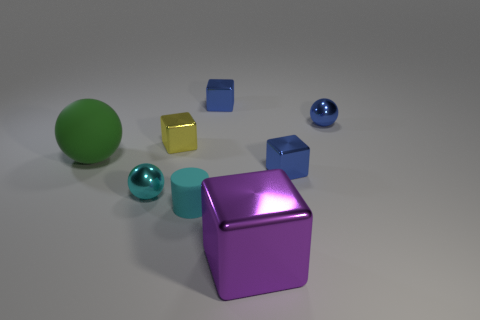How many things are either tiny blue metallic cubes that are behind the small yellow shiny cube or green things?
Keep it short and to the point. 2. Are there the same number of small spheres that are on the left side of the purple metallic block and tiny metallic cubes in front of the tiny yellow metal object?
Offer a very short reply. Yes. The tiny cyan cylinder to the left of the tiny blue metal object that is to the left of the block right of the purple thing is made of what material?
Make the answer very short. Rubber. How big is the thing that is both behind the purple cube and in front of the cyan sphere?
Give a very brief answer. Small. Does the purple thing have the same shape as the big green matte object?
Your answer should be very brief. No. What shape is the yellow object that is the same material as the purple cube?
Provide a succinct answer. Cube. How many large objects are either cyan shiny objects or blue metal cylinders?
Your answer should be compact. 0. Is there a small cyan shiny ball that is in front of the blue object that is in front of the green thing?
Provide a succinct answer. Yes. Is there a blue ball?
Provide a succinct answer. Yes. There is a big sphere to the left of the cyan thing on the left side of the cyan cylinder; what color is it?
Provide a short and direct response. Green. 